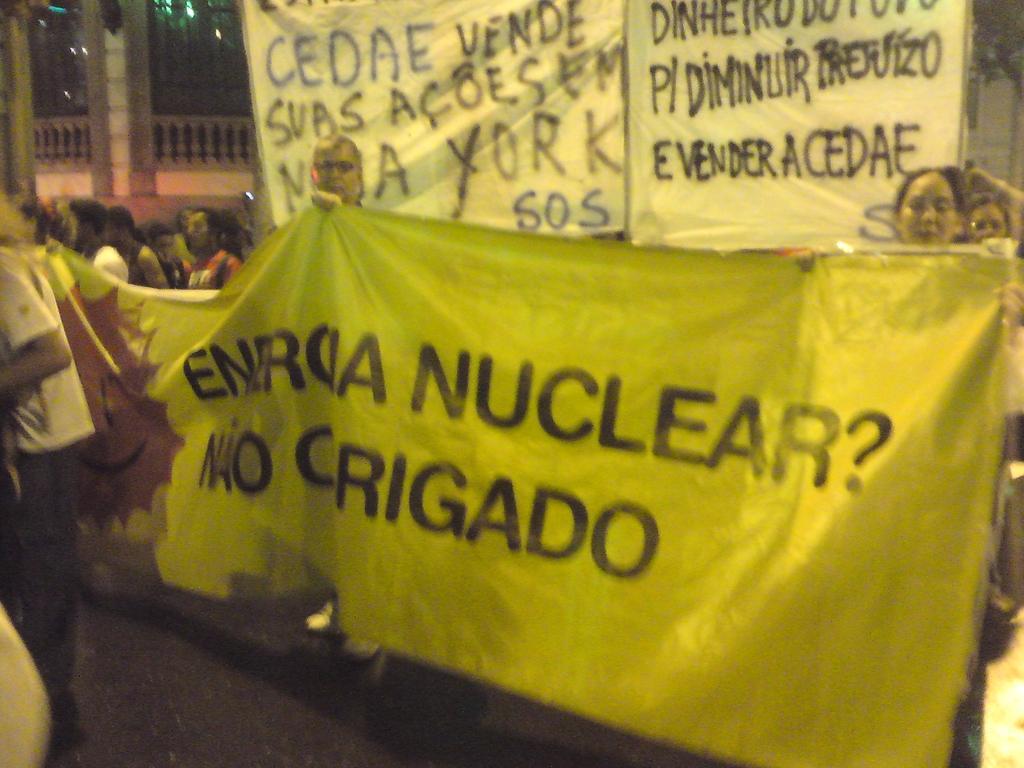How would you summarize this image in a sentence or two? In the image we can see there are many people wearing clothes, this is a footpath, banner and a fence. We can even see light. 